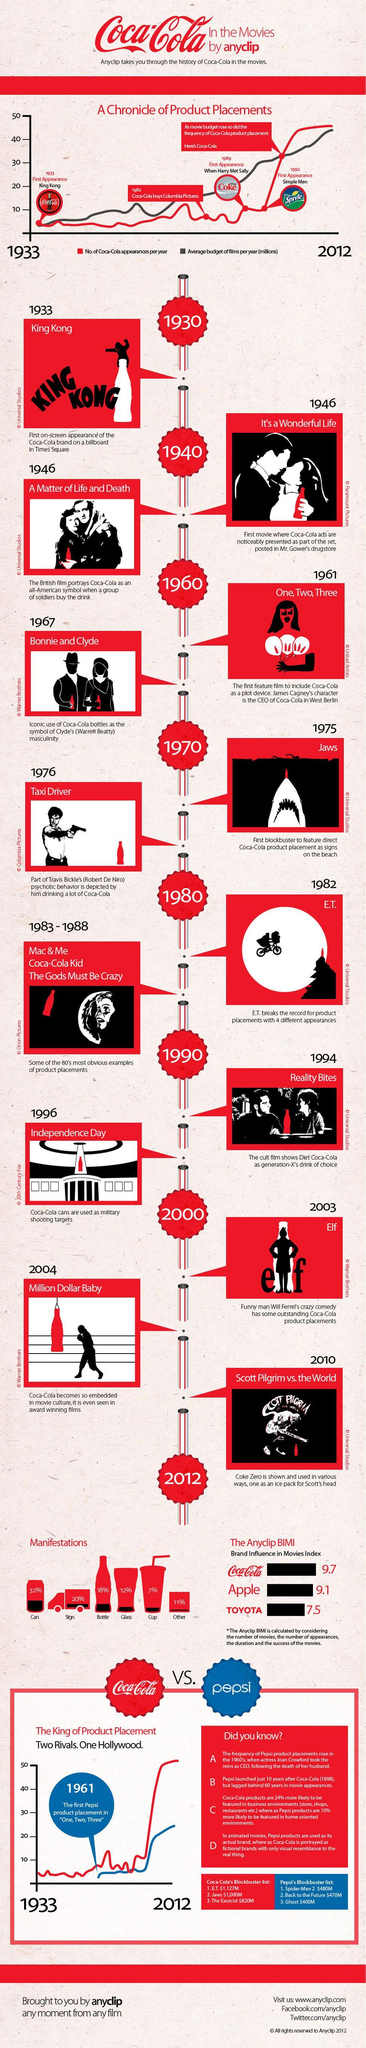What percentage of Coca-Cola bottles are made as per the manifestation?
Answer the question with a short phrase. 18% In which movie, the Coca-Cola cans were used as military shooting targets? Independence Day What is the Brand Influence in Movies Index of Coca-Cola? 9.7 What percentage of Coca-Cola cups are made as per manifestation? 7% Which year the Coca-Cola brand had first on-screen appearance? 1933 Which movie gave Coca-Cola brand the first on-screen appearance on a billboard in Times Square? King Kong Which movie featured direct Coca-Cola product placement as signs on the beach? Jaws 